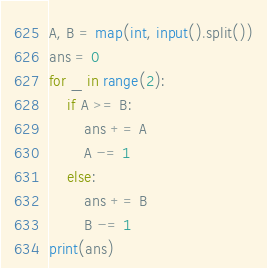<code> <loc_0><loc_0><loc_500><loc_500><_Python_>A, B = map(int, input().split())
ans = 0
for _ in range(2):
    if A >= B:
        ans += A
        A -= 1
    else:
        ans += B
        B -= 1
print(ans)
</code> 